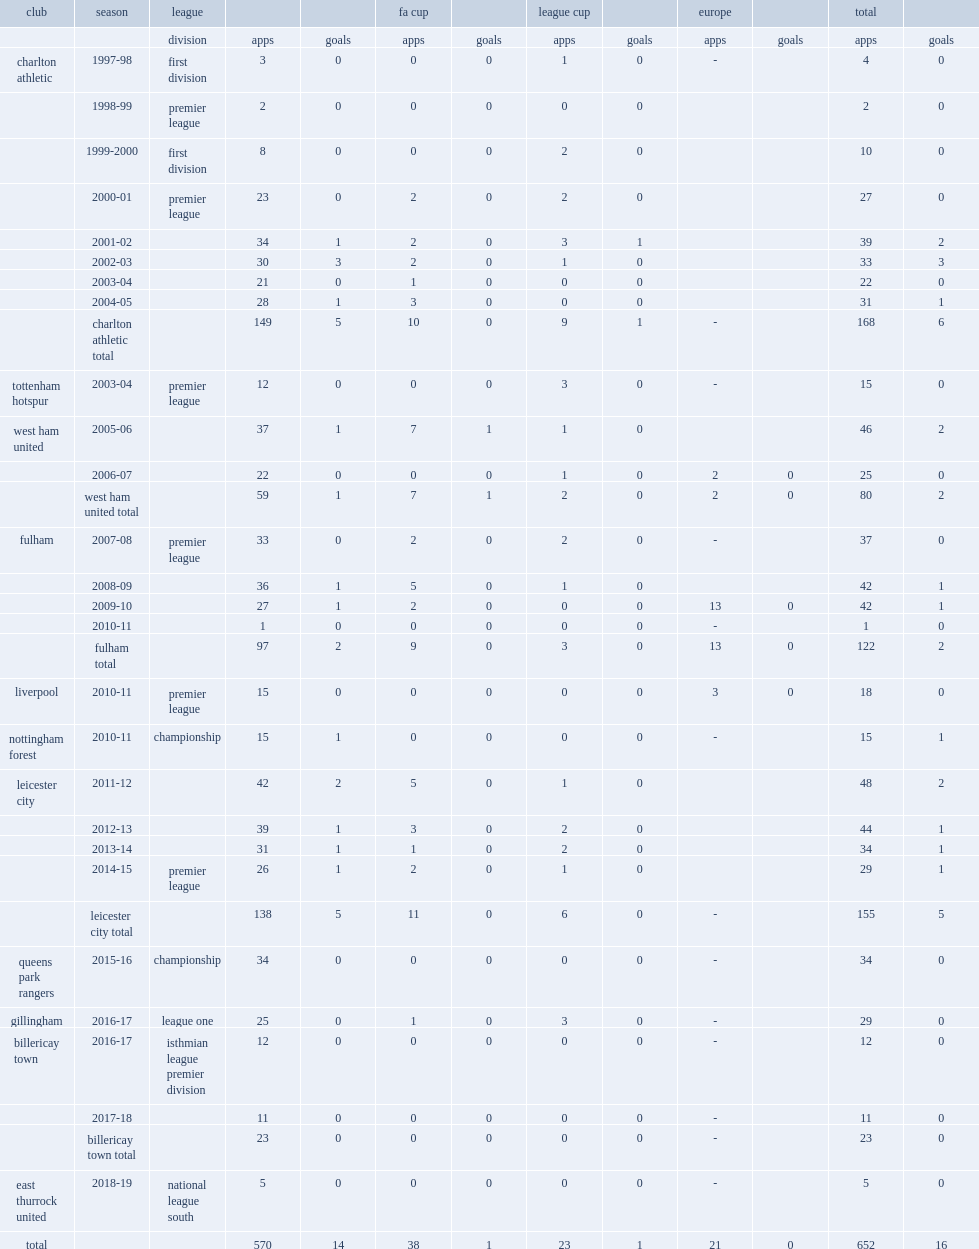Which league did paul konchesky play for fulham in the 2008-09 season? Premier league. 